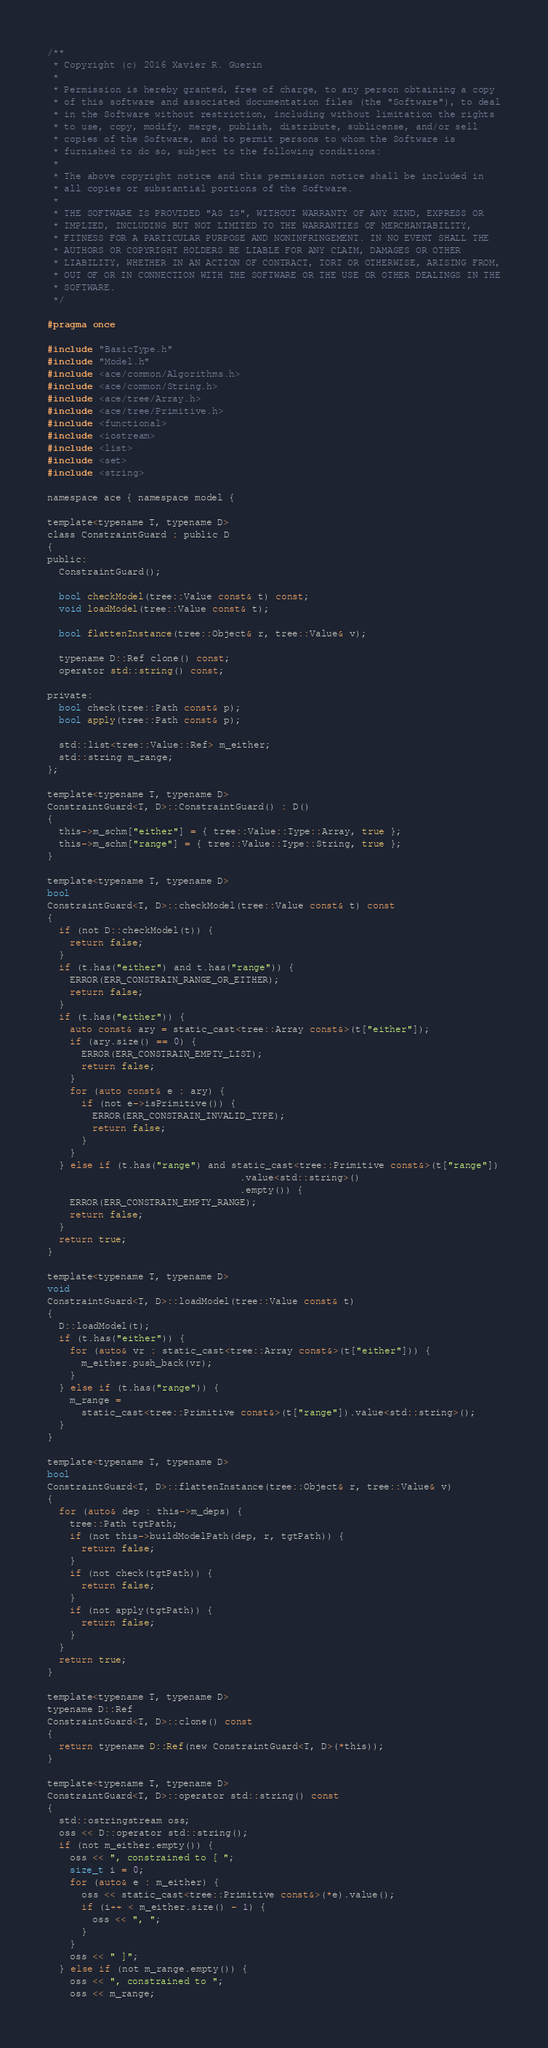Convert code to text. <code><loc_0><loc_0><loc_500><loc_500><_C_>/**
 * Copyright (c) 2016 Xavier R. Guerin
 *
 * Permission is hereby granted, free of charge, to any person obtaining a copy
 * of this software and associated documentation files (the "Software"), to deal
 * in the Software without restriction, including without limitation the rights
 * to use, copy, modify, merge, publish, distribute, sublicense, and/or sell
 * copies of the Software, and to permit persons to whom the Software is
 * furnished to do so, subject to the following conditions:
 *
 * The above copyright notice and this permission notice shall be included in
 * all copies or substantial portions of the Software.
 *
 * THE SOFTWARE IS PROVIDED "AS IS", WITHOUT WARRANTY OF ANY KIND, EXPRESS OR
 * IMPLIED, INCLUDING BUT NOT LIMITED TO THE WARRANTIES OF MERCHANTABILITY,
 * FITNESS FOR A PARTICULAR PURPOSE AND NONINFRINGEMENT. IN NO EVENT SHALL THE
 * AUTHORS OR COPYRIGHT HOLDERS BE LIABLE FOR ANY CLAIM, DAMAGES OR OTHER
 * LIABILITY, WHETHER IN AN ACTION OF CONTRACT, TORT OR OTHERWISE, ARISING FROM,
 * OUT OF OR IN CONNECTION WITH THE SOFTWARE OR THE USE OR OTHER DEALINGS IN THE
 * SOFTWARE.
 */

#pragma once

#include "BasicType.h"
#include "Model.h"
#include <ace/common/Algorithms.h>
#include <ace/common/String.h>
#include <ace/tree/Array.h>
#include <ace/tree/Primitive.h>
#include <functional>
#include <iostream>
#include <list>
#include <set>
#include <string>

namespace ace { namespace model {

template<typename T, typename D>
class ConstraintGuard : public D
{
public:
  ConstraintGuard();

  bool checkModel(tree::Value const& t) const;
  void loadModel(tree::Value const& t);

  bool flattenInstance(tree::Object& r, tree::Value& v);

  typename D::Ref clone() const;
  operator std::string() const;

private:
  bool check(tree::Path const& p);
  bool apply(tree::Path const& p);

  std::list<tree::Value::Ref> m_either;
  std::string m_range;
};

template<typename T, typename D>
ConstraintGuard<T, D>::ConstraintGuard() : D()
{
  this->m_schm["either"] = { tree::Value::Type::Array, true };
  this->m_schm["range"] = { tree::Value::Type::String, true };
}

template<typename T, typename D>
bool
ConstraintGuard<T, D>::checkModel(tree::Value const& t) const
{
  if (not D::checkModel(t)) {
    return false;
  }
  if (t.has("either") and t.has("range")) {
    ERROR(ERR_CONSTRAIN_RANGE_OR_EITHER);
    return false;
  }
  if (t.has("either")) {
    auto const& ary = static_cast<tree::Array const&>(t["either"]);
    if (ary.size() == 0) {
      ERROR(ERR_CONSTRAIN_EMPTY_LIST);
      return false;
    }
    for (auto const& e : ary) {
      if (not e->isPrimitive()) {
        ERROR(ERR_CONSTRAIN_INVALID_TYPE);
        return false;
      }
    }
  } else if (t.has("range") and static_cast<tree::Primitive const&>(t["range"])
                                  .value<std::string>()
                                  .empty()) {
    ERROR(ERR_CONSTRAIN_EMPTY_RANGE);
    return false;
  }
  return true;
}

template<typename T, typename D>
void
ConstraintGuard<T, D>::loadModel(tree::Value const& t)
{
  D::loadModel(t);
  if (t.has("either")) {
    for (auto& vr : static_cast<tree::Array const&>(t["either"])) {
      m_either.push_back(vr);
    }
  } else if (t.has("range")) {
    m_range =
      static_cast<tree::Primitive const&>(t["range"]).value<std::string>();
  }
}

template<typename T, typename D>
bool
ConstraintGuard<T, D>::flattenInstance(tree::Object& r, tree::Value& v)
{
  for (auto& dep : this->m_deps) {
    tree::Path tgtPath;
    if (not this->buildModelPath(dep, r, tgtPath)) {
      return false;
    }
    if (not check(tgtPath)) {
      return false;
    }
    if (not apply(tgtPath)) {
      return false;
    }
  }
  return true;
}

template<typename T, typename D>
typename D::Ref
ConstraintGuard<T, D>::clone() const
{
  return typename D::Ref(new ConstraintGuard<T, D>(*this));
}

template<typename T, typename D>
ConstraintGuard<T, D>::operator std::string() const
{
  std::ostringstream oss;
  oss << D::operator std::string();
  if (not m_either.empty()) {
    oss << ", constrained to [ ";
    size_t i = 0;
    for (auto& e : m_either) {
      oss << static_cast<tree::Primitive const&>(*e).value();
      if (i++ < m_either.size() - 1) {
        oss << ", ";
      }
    }
    oss << " ]";
  } else if (not m_range.empty()) {
    oss << ", constrained to ";
    oss << m_range;</code> 